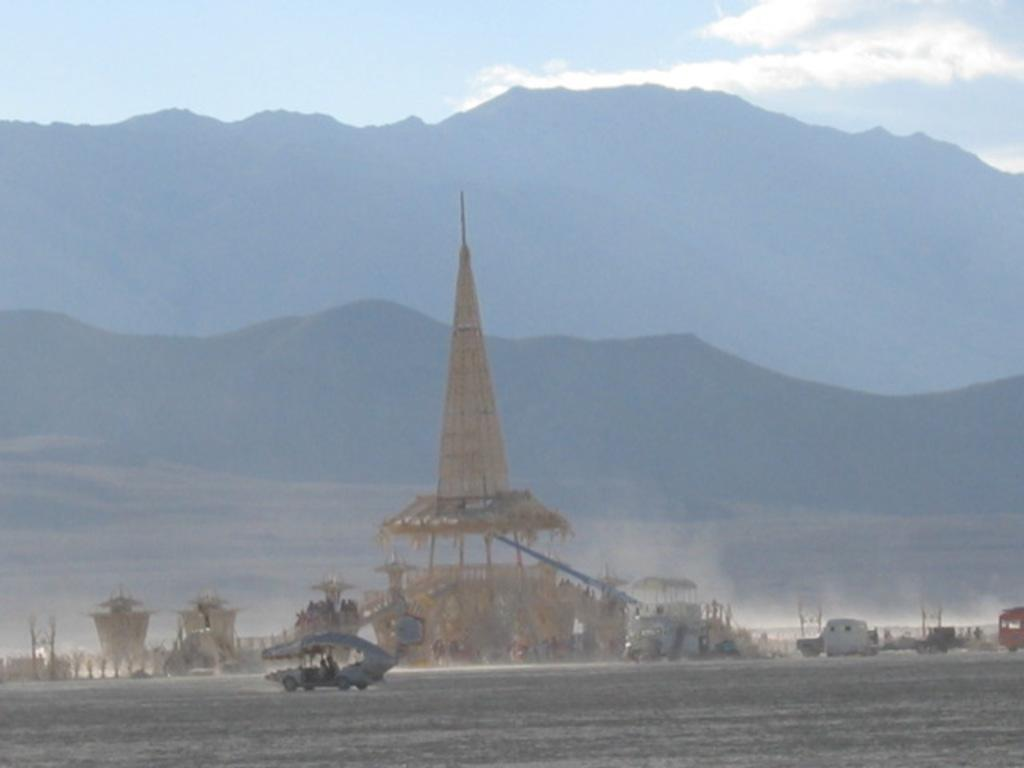What can be seen in the image? There are vehicles in the image. What else is present near the vehicles? There are objects beside the vehicles. What can be seen in the distance in the image? There are mountains in the background of the image. What type of plants can be seen growing on the beef in the image? There is no beef or plants present in the image. 